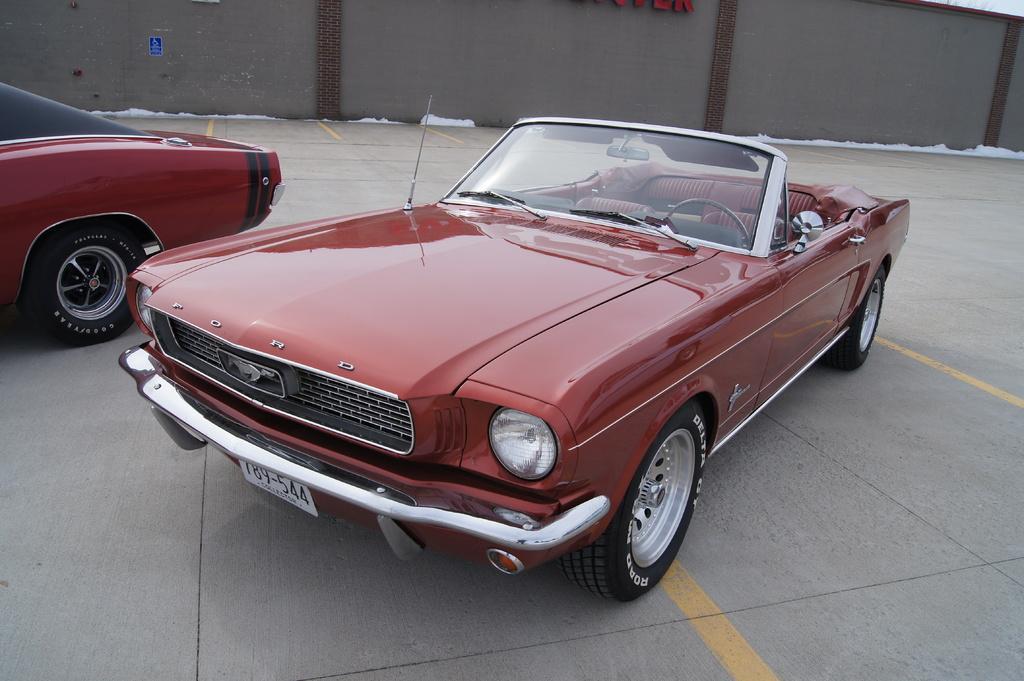Describe this image in one or two sentences. In this image in the center there are two cars, and in the background there is wall, text and some cotton. At the bottom there is walkway. 